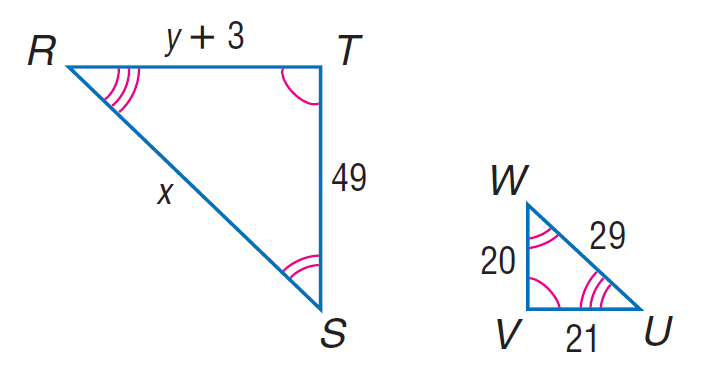Question: Each pair of polygons is similar. Find y.
Choices:
A. 48.45
B. 49
C. 88
D. 110
Answer with the letter. Answer: A Question: Each pair of polygons is similar. Find x.
Choices:
A. 29
B. 55.3
C. 71.05
D. 78
Answer with the letter. Answer: C 